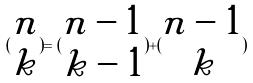Convert formula to latex. <formula><loc_0><loc_0><loc_500><loc_500>( \begin{matrix} n \\ k \end{matrix} ) = ( \begin{matrix} n - 1 \\ k - 1 \end{matrix} ) + ( \begin{matrix} n - 1 \\ k \end{matrix} )</formula> 